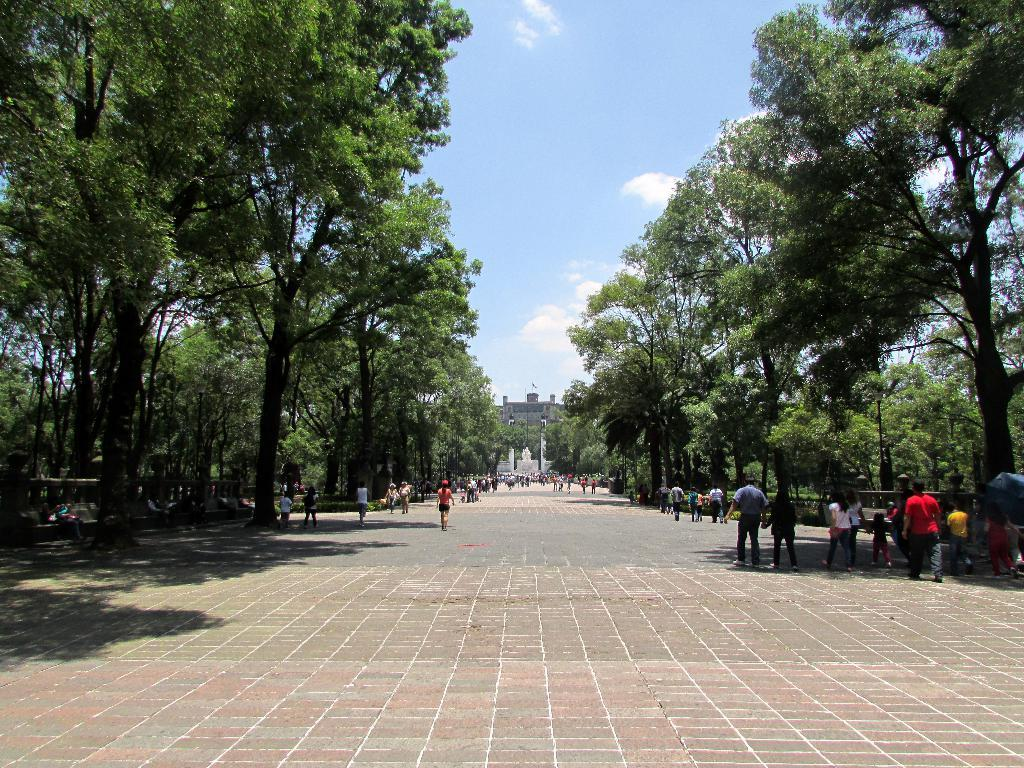What is happening on the road in the image? There are persons on the road in the image. What type of natural elements can be seen in the image? Trees are visible in the image. What type of structure is present in the background? There is a building in the background. What is visible in the sky in the image? The sky is visible with clouds in the background. What type of drink is being served at the vacation spot in the image? There is no vacation spot or drink present in the image. What type of view can be seen from the building in the image? There is no view visible from the building in the image; only the building itself is present. 